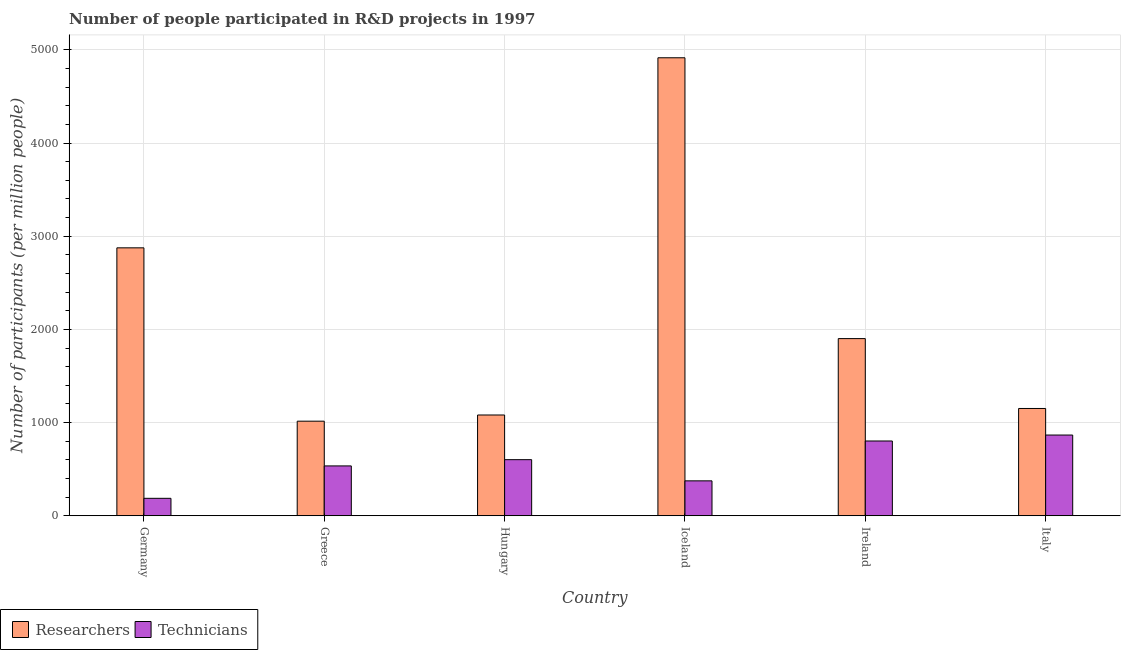How many groups of bars are there?
Offer a terse response. 6. Are the number of bars per tick equal to the number of legend labels?
Offer a terse response. Yes. Are the number of bars on each tick of the X-axis equal?
Give a very brief answer. Yes. How many bars are there on the 6th tick from the right?
Ensure brevity in your answer.  2. What is the label of the 5th group of bars from the left?
Provide a short and direct response. Ireland. In how many cases, is the number of bars for a given country not equal to the number of legend labels?
Give a very brief answer. 0. What is the number of technicians in Iceland?
Offer a very short reply. 374.99. Across all countries, what is the maximum number of researchers?
Make the answer very short. 4915.36. Across all countries, what is the minimum number of technicians?
Give a very brief answer. 187.58. What is the total number of researchers in the graph?
Your answer should be compact. 1.29e+04. What is the difference between the number of researchers in Greece and that in Ireland?
Make the answer very short. -886.22. What is the difference between the number of researchers in Iceland and the number of technicians in Hungary?
Your response must be concise. 4313.06. What is the average number of technicians per country?
Offer a terse response. 561.6. What is the difference between the number of researchers and number of technicians in Germany?
Your answer should be very brief. 2688.16. In how many countries, is the number of researchers greater than 3400 ?
Your answer should be very brief. 1. What is the ratio of the number of researchers in Ireland to that in Italy?
Ensure brevity in your answer.  1.65. What is the difference between the highest and the second highest number of researchers?
Your answer should be compact. 2039.62. What is the difference between the highest and the lowest number of technicians?
Your response must be concise. 679.09. What does the 2nd bar from the left in Iceland represents?
Keep it short and to the point. Technicians. What does the 1st bar from the right in Germany represents?
Your response must be concise. Technicians. Does the graph contain any zero values?
Offer a terse response. No. Where does the legend appear in the graph?
Ensure brevity in your answer.  Bottom left. How are the legend labels stacked?
Your response must be concise. Horizontal. What is the title of the graph?
Your response must be concise. Number of people participated in R&D projects in 1997. Does "Measles" appear as one of the legend labels in the graph?
Offer a very short reply. No. What is the label or title of the X-axis?
Your response must be concise. Country. What is the label or title of the Y-axis?
Your answer should be very brief. Number of participants (per million people). What is the Number of participants (per million people) in Researchers in Germany?
Provide a short and direct response. 2875.74. What is the Number of participants (per million people) in Technicians in Germany?
Offer a terse response. 187.58. What is the Number of participants (per million people) of Researchers in Greece?
Offer a terse response. 1015.39. What is the Number of participants (per million people) in Technicians in Greece?
Offer a very short reply. 535.23. What is the Number of participants (per million people) of Researchers in Hungary?
Give a very brief answer. 1081.73. What is the Number of participants (per million people) in Technicians in Hungary?
Make the answer very short. 602.3. What is the Number of participants (per million people) in Researchers in Iceland?
Offer a terse response. 4915.36. What is the Number of participants (per million people) in Technicians in Iceland?
Keep it short and to the point. 374.99. What is the Number of participants (per million people) in Researchers in Ireland?
Offer a terse response. 1901.61. What is the Number of participants (per million people) in Technicians in Ireland?
Make the answer very short. 802.83. What is the Number of participants (per million people) in Researchers in Italy?
Offer a terse response. 1151.62. What is the Number of participants (per million people) of Technicians in Italy?
Offer a terse response. 866.67. Across all countries, what is the maximum Number of participants (per million people) in Researchers?
Make the answer very short. 4915.36. Across all countries, what is the maximum Number of participants (per million people) in Technicians?
Your answer should be compact. 866.67. Across all countries, what is the minimum Number of participants (per million people) of Researchers?
Your answer should be very brief. 1015.39. Across all countries, what is the minimum Number of participants (per million people) of Technicians?
Your response must be concise. 187.58. What is the total Number of participants (per million people) in Researchers in the graph?
Keep it short and to the point. 1.29e+04. What is the total Number of participants (per million people) of Technicians in the graph?
Offer a terse response. 3369.59. What is the difference between the Number of participants (per million people) in Researchers in Germany and that in Greece?
Offer a very short reply. 1860.35. What is the difference between the Number of participants (per million people) of Technicians in Germany and that in Greece?
Offer a very short reply. -347.65. What is the difference between the Number of participants (per million people) in Researchers in Germany and that in Hungary?
Ensure brevity in your answer.  1794.01. What is the difference between the Number of participants (per million people) in Technicians in Germany and that in Hungary?
Offer a terse response. -414.72. What is the difference between the Number of participants (per million people) of Researchers in Germany and that in Iceland?
Offer a terse response. -2039.62. What is the difference between the Number of participants (per million people) of Technicians in Germany and that in Iceland?
Provide a succinct answer. -187.41. What is the difference between the Number of participants (per million people) of Researchers in Germany and that in Ireland?
Ensure brevity in your answer.  974.13. What is the difference between the Number of participants (per million people) in Technicians in Germany and that in Ireland?
Provide a succinct answer. -615.25. What is the difference between the Number of participants (per million people) of Researchers in Germany and that in Italy?
Offer a terse response. 1724.12. What is the difference between the Number of participants (per million people) in Technicians in Germany and that in Italy?
Make the answer very short. -679.09. What is the difference between the Number of participants (per million people) of Researchers in Greece and that in Hungary?
Give a very brief answer. -66.34. What is the difference between the Number of participants (per million people) in Technicians in Greece and that in Hungary?
Give a very brief answer. -67.07. What is the difference between the Number of participants (per million people) in Researchers in Greece and that in Iceland?
Make the answer very short. -3899.97. What is the difference between the Number of participants (per million people) of Technicians in Greece and that in Iceland?
Offer a very short reply. 160.24. What is the difference between the Number of participants (per million people) of Researchers in Greece and that in Ireland?
Give a very brief answer. -886.22. What is the difference between the Number of participants (per million people) of Technicians in Greece and that in Ireland?
Your answer should be very brief. -267.6. What is the difference between the Number of participants (per million people) of Researchers in Greece and that in Italy?
Provide a succinct answer. -136.23. What is the difference between the Number of participants (per million people) in Technicians in Greece and that in Italy?
Provide a succinct answer. -331.44. What is the difference between the Number of participants (per million people) of Researchers in Hungary and that in Iceland?
Your answer should be compact. -3833.63. What is the difference between the Number of participants (per million people) of Technicians in Hungary and that in Iceland?
Give a very brief answer. 227.3. What is the difference between the Number of participants (per million people) in Researchers in Hungary and that in Ireland?
Offer a terse response. -819.88. What is the difference between the Number of participants (per million people) of Technicians in Hungary and that in Ireland?
Your answer should be very brief. -200.53. What is the difference between the Number of participants (per million people) in Researchers in Hungary and that in Italy?
Your answer should be compact. -69.89. What is the difference between the Number of participants (per million people) in Technicians in Hungary and that in Italy?
Your answer should be very brief. -264.37. What is the difference between the Number of participants (per million people) of Researchers in Iceland and that in Ireland?
Provide a short and direct response. 3013.74. What is the difference between the Number of participants (per million people) in Technicians in Iceland and that in Ireland?
Your answer should be compact. -427.84. What is the difference between the Number of participants (per million people) of Researchers in Iceland and that in Italy?
Your answer should be compact. 3763.73. What is the difference between the Number of participants (per million people) of Technicians in Iceland and that in Italy?
Keep it short and to the point. -491.68. What is the difference between the Number of participants (per million people) in Researchers in Ireland and that in Italy?
Your answer should be very brief. 749.99. What is the difference between the Number of participants (per million people) of Technicians in Ireland and that in Italy?
Your response must be concise. -63.84. What is the difference between the Number of participants (per million people) of Researchers in Germany and the Number of participants (per million people) of Technicians in Greece?
Provide a short and direct response. 2340.51. What is the difference between the Number of participants (per million people) in Researchers in Germany and the Number of participants (per million people) in Technicians in Hungary?
Keep it short and to the point. 2273.44. What is the difference between the Number of participants (per million people) in Researchers in Germany and the Number of participants (per million people) in Technicians in Iceland?
Your answer should be compact. 2500.75. What is the difference between the Number of participants (per million people) in Researchers in Germany and the Number of participants (per million people) in Technicians in Ireland?
Keep it short and to the point. 2072.91. What is the difference between the Number of participants (per million people) in Researchers in Germany and the Number of participants (per million people) in Technicians in Italy?
Your answer should be very brief. 2009.07. What is the difference between the Number of participants (per million people) in Researchers in Greece and the Number of participants (per million people) in Technicians in Hungary?
Give a very brief answer. 413.1. What is the difference between the Number of participants (per million people) in Researchers in Greece and the Number of participants (per million people) in Technicians in Iceland?
Offer a terse response. 640.4. What is the difference between the Number of participants (per million people) in Researchers in Greece and the Number of participants (per million people) in Technicians in Ireland?
Your answer should be very brief. 212.56. What is the difference between the Number of participants (per million people) in Researchers in Greece and the Number of participants (per million people) in Technicians in Italy?
Your answer should be compact. 148.73. What is the difference between the Number of participants (per million people) of Researchers in Hungary and the Number of participants (per million people) of Technicians in Iceland?
Offer a terse response. 706.74. What is the difference between the Number of participants (per million people) of Researchers in Hungary and the Number of participants (per million people) of Technicians in Ireland?
Make the answer very short. 278.91. What is the difference between the Number of participants (per million people) of Researchers in Hungary and the Number of participants (per million people) of Technicians in Italy?
Your answer should be compact. 215.07. What is the difference between the Number of participants (per million people) in Researchers in Iceland and the Number of participants (per million people) in Technicians in Ireland?
Keep it short and to the point. 4112.53. What is the difference between the Number of participants (per million people) of Researchers in Iceland and the Number of participants (per million people) of Technicians in Italy?
Provide a short and direct response. 4048.69. What is the difference between the Number of participants (per million people) in Researchers in Ireland and the Number of participants (per million people) in Technicians in Italy?
Give a very brief answer. 1034.95. What is the average Number of participants (per million people) in Researchers per country?
Keep it short and to the point. 2156.91. What is the average Number of participants (per million people) in Technicians per country?
Provide a succinct answer. 561.6. What is the difference between the Number of participants (per million people) in Researchers and Number of participants (per million people) in Technicians in Germany?
Keep it short and to the point. 2688.16. What is the difference between the Number of participants (per million people) of Researchers and Number of participants (per million people) of Technicians in Greece?
Your answer should be compact. 480.17. What is the difference between the Number of participants (per million people) of Researchers and Number of participants (per million people) of Technicians in Hungary?
Your answer should be compact. 479.44. What is the difference between the Number of participants (per million people) of Researchers and Number of participants (per million people) of Technicians in Iceland?
Provide a succinct answer. 4540.37. What is the difference between the Number of participants (per million people) in Researchers and Number of participants (per million people) in Technicians in Ireland?
Your answer should be compact. 1098.79. What is the difference between the Number of participants (per million people) in Researchers and Number of participants (per million people) in Technicians in Italy?
Ensure brevity in your answer.  284.96. What is the ratio of the Number of participants (per million people) in Researchers in Germany to that in Greece?
Give a very brief answer. 2.83. What is the ratio of the Number of participants (per million people) in Technicians in Germany to that in Greece?
Provide a short and direct response. 0.35. What is the ratio of the Number of participants (per million people) in Researchers in Germany to that in Hungary?
Your answer should be compact. 2.66. What is the ratio of the Number of participants (per million people) of Technicians in Germany to that in Hungary?
Ensure brevity in your answer.  0.31. What is the ratio of the Number of participants (per million people) in Researchers in Germany to that in Iceland?
Offer a very short reply. 0.59. What is the ratio of the Number of participants (per million people) of Technicians in Germany to that in Iceland?
Your response must be concise. 0.5. What is the ratio of the Number of participants (per million people) of Researchers in Germany to that in Ireland?
Provide a short and direct response. 1.51. What is the ratio of the Number of participants (per million people) in Technicians in Germany to that in Ireland?
Your response must be concise. 0.23. What is the ratio of the Number of participants (per million people) in Researchers in Germany to that in Italy?
Ensure brevity in your answer.  2.5. What is the ratio of the Number of participants (per million people) of Technicians in Germany to that in Italy?
Provide a succinct answer. 0.22. What is the ratio of the Number of participants (per million people) of Researchers in Greece to that in Hungary?
Your answer should be very brief. 0.94. What is the ratio of the Number of participants (per million people) of Technicians in Greece to that in Hungary?
Provide a short and direct response. 0.89. What is the ratio of the Number of participants (per million people) in Researchers in Greece to that in Iceland?
Your response must be concise. 0.21. What is the ratio of the Number of participants (per million people) in Technicians in Greece to that in Iceland?
Make the answer very short. 1.43. What is the ratio of the Number of participants (per million people) of Researchers in Greece to that in Ireland?
Give a very brief answer. 0.53. What is the ratio of the Number of participants (per million people) in Researchers in Greece to that in Italy?
Keep it short and to the point. 0.88. What is the ratio of the Number of participants (per million people) of Technicians in Greece to that in Italy?
Your response must be concise. 0.62. What is the ratio of the Number of participants (per million people) in Researchers in Hungary to that in Iceland?
Your answer should be very brief. 0.22. What is the ratio of the Number of participants (per million people) in Technicians in Hungary to that in Iceland?
Ensure brevity in your answer.  1.61. What is the ratio of the Number of participants (per million people) of Researchers in Hungary to that in Ireland?
Keep it short and to the point. 0.57. What is the ratio of the Number of participants (per million people) of Technicians in Hungary to that in Ireland?
Your answer should be very brief. 0.75. What is the ratio of the Number of participants (per million people) in Researchers in Hungary to that in Italy?
Give a very brief answer. 0.94. What is the ratio of the Number of participants (per million people) of Technicians in Hungary to that in Italy?
Offer a very short reply. 0.69. What is the ratio of the Number of participants (per million people) of Researchers in Iceland to that in Ireland?
Your answer should be compact. 2.58. What is the ratio of the Number of participants (per million people) in Technicians in Iceland to that in Ireland?
Your answer should be very brief. 0.47. What is the ratio of the Number of participants (per million people) of Researchers in Iceland to that in Italy?
Provide a succinct answer. 4.27. What is the ratio of the Number of participants (per million people) of Technicians in Iceland to that in Italy?
Your answer should be very brief. 0.43. What is the ratio of the Number of participants (per million people) in Researchers in Ireland to that in Italy?
Offer a terse response. 1.65. What is the ratio of the Number of participants (per million people) of Technicians in Ireland to that in Italy?
Ensure brevity in your answer.  0.93. What is the difference between the highest and the second highest Number of participants (per million people) of Researchers?
Ensure brevity in your answer.  2039.62. What is the difference between the highest and the second highest Number of participants (per million people) of Technicians?
Make the answer very short. 63.84. What is the difference between the highest and the lowest Number of participants (per million people) of Researchers?
Keep it short and to the point. 3899.97. What is the difference between the highest and the lowest Number of participants (per million people) in Technicians?
Make the answer very short. 679.09. 